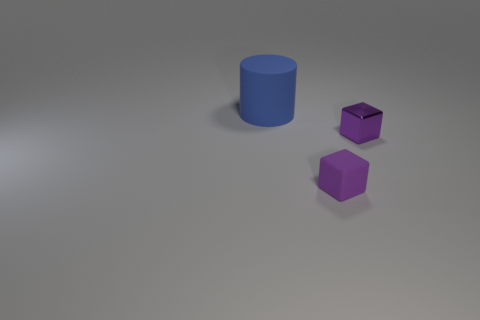What is the material of the other thing that is the same color as the metal object?
Provide a short and direct response. Rubber. There is a small purple object that is behind the matte object to the right of the rubber cylinder; is there a matte cylinder in front of it?
Your answer should be compact. No. Are there more tiny purple matte things that are in front of the tiny purple matte cube than tiny purple cubes behind the cylinder?
Offer a very short reply. No. There is another purple object that is the same size as the purple metallic thing; what is its material?
Provide a succinct answer. Rubber. What number of big objects are metallic blocks or red spheres?
Ensure brevity in your answer.  0. Does the tiny metal thing have the same shape as the large thing?
Your answer should be very brief. No. What number of things are both in front of the small shiny block and behind the small shiny object?
Your answer should be compact. 0. Is there anything else that has the same color as the matte cylinder?
Provide a short and direct response. No. The purple object that is the same material as the blue object is what shape?
Give a very brief answer. Cube. Do the matte cylinder and the purple matte object have the same size?
Give a very brief answer. No. 